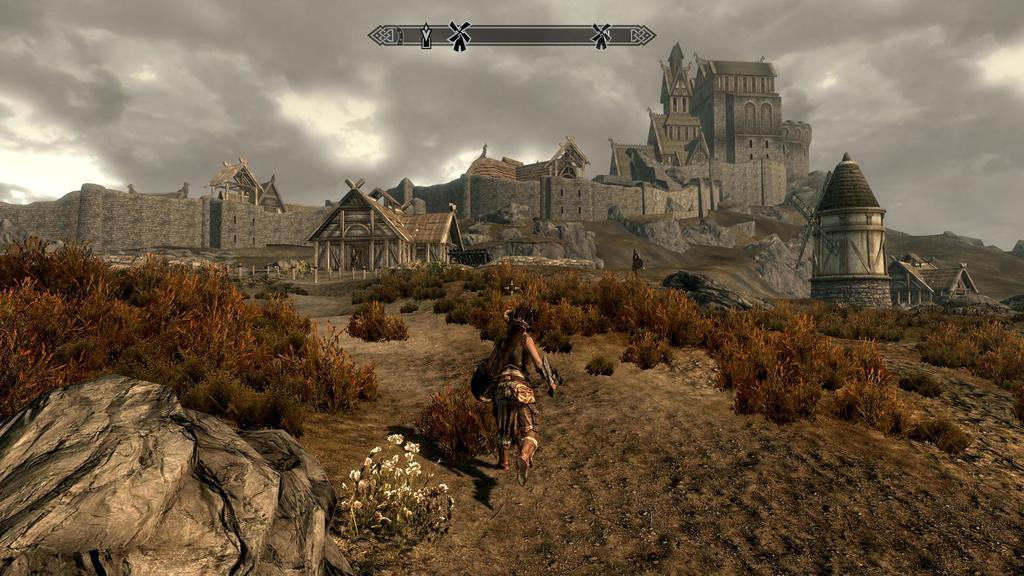What can be seen in the background of the image? The background of the image includes the sky, a fort, and houses. What is the person in the image doing? The person is walking in the image. What type of natural elements are present in the image? The image contains plants, rocks, and flowers. What type of pleasure can be seen in the image? There is no indication of pleasure in the image; it features a person walking in a natural environment with a fort, houses, plants, rocks, and flowers. What color is the person's hair in the image? The image does not show the person's hair, so it cannot be determined from the image. 